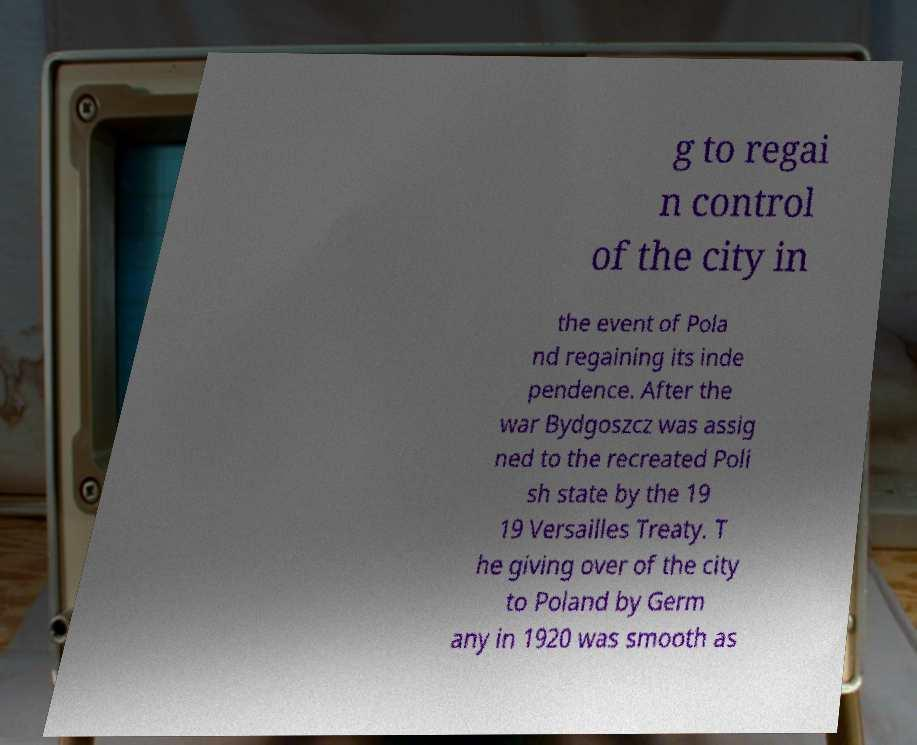What messages or text are displayed in this image? I need them in a readable, typed format. g to regai n control of the city in the event of Pola nd regaining its inde pendence. After the war Bydgoszcz was assig ned to the recreated Poli sh state by the 19 19 Versailles Treaty. T he giving over of the city to Poland by Germ any in 1920 was smooth as 